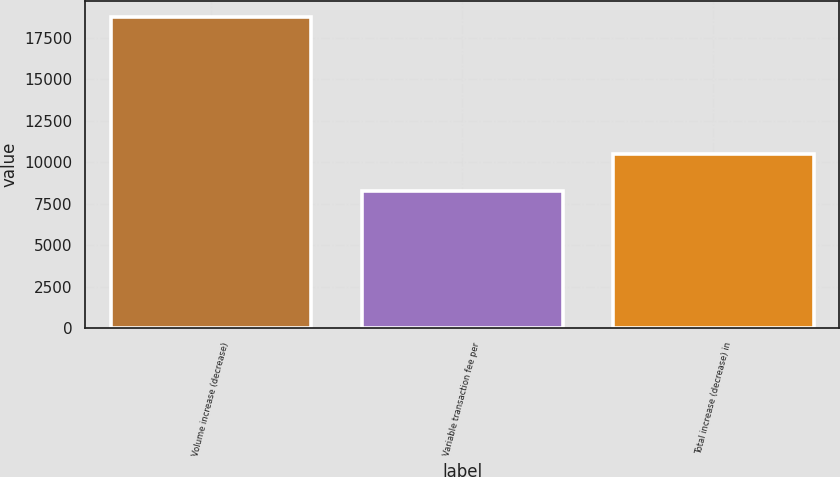Convert chart to OTSL. <chart><loc_0><loc_0><loc_500><loc_500><bar_chart><fcel>Volume increase (decrease)<fcel>Variable transaction fee per<fcel>Total increase (decrease) in<nl><fcel>18762<fcel>8246<fcel>10516<nl></chart> 